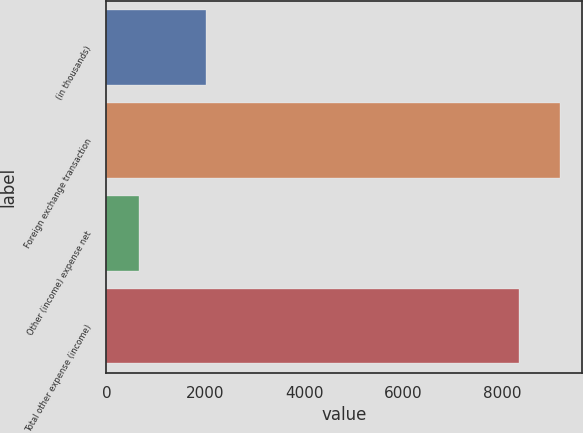Convert chart to OTSL. <chart><loc_0><loc_0><loc_500><loc_500><bar_chart><fcel>(in thousands)<fcel>Foreign exchange transaction<fcel>Other (income) expense net<fcel>Total other expense (income)<nl><fcel>2013<fcel>9161.9<fcel>653<fcel>8329<nl></chart> 